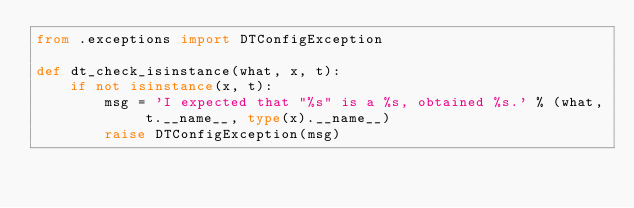Convert code to text. <code><loc_0><loc_0><loc_500><loc_500><_Python_>from .exceptions import DTConfigException

def dt_check_isinstance(what, x, t):
    if not isinstance(x, t):
        msg = 'I expected that "%s" is a %s, obtained %s.' % (what, t.__name__, type(x).__name__) 
        raise DTConfigException(msg)</code> 